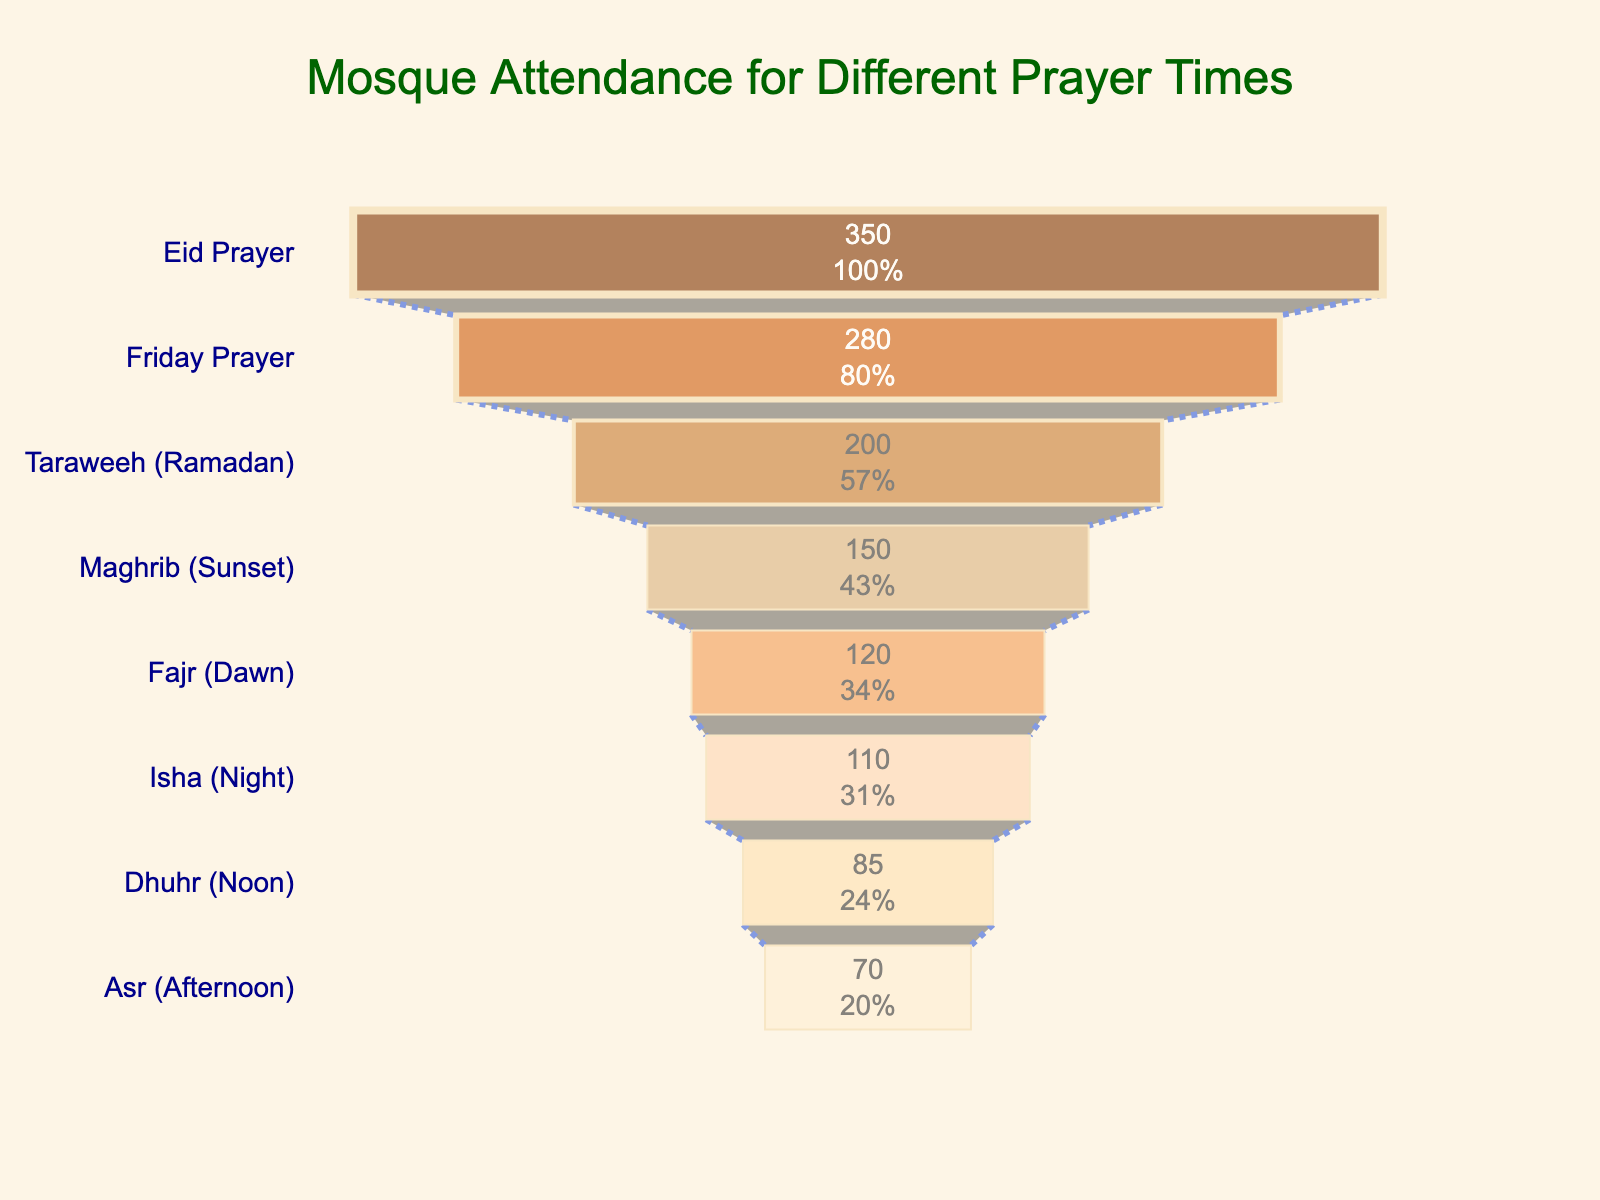what's the title of the funnel chart? The title of the chart is displayed at the top. In this case, it is centered and formatted in a readable font and color.
Answer: Mosque Attendance for Different Prayer Times how many different prayer times are represented in the funnel chart? By counting the different sections of the funnel chart, we can see that there are eight different prayer times shown.
Answer: 8 what prayer time has the highest attendance? We look at the top-most section of the funnel, which represents the prayer time with the highest attendee number.
Answer: Eid Prayer how many people attend the Friday prayer? The funnel segment labeled "Friday Prayer" shows the number of attendees inside. This specific segment indicates the attendee count.
Answer: 280 what's the difference in attendance between Fajr (Dawn) and Isha (Night) prayers? Find the segments for Fajr (Dawn) and Isha (Night) and subtract the smaller number from the larger number: 120 (Fajr) - 110 (Isha)
Answer: 10 which prayer time has fewer attendees, Dhuhr (Noon) or Asr (Afternoon)? Compare the "Dhuhr (Noon)" and "Asr (Afternoon)" segments by looking at their respective attendee counts.
Answer: Asr (Afternoon) how does the attendance for Taraweeh during Ramadan compare to the Friday prayer? Compare the heights of the "Taraweeh (Ramadan)" and "Friday Prayer" segments, noting that the "Friday Prayer" has more attendees.
Answer: Friday Prayer has more attendees what fraction of the total Eid Prayer attendance is represented by Maghrib (Sunset) prayer? Divide the number of attendees for Maghrib (Sunset) by the number for Eid Prayer: 150 / 350
Answer: 3/7 rank the prayer times in descending order of attendance. List all the prayer times by descending the number of attendees displayed in their segments. It will produce the ordered list: Eid Prayer, Taraweeh (Ramadan), Friday Prayer, Maghrib (Sunset), Fajr (Dawn), Isha (Night), Dhuhr (Noon), Asr (Afternoon).
Answer: Eid Prayer > Taraweeh (Ramadan) > Friday Prayer > Maghrib (Sunset) > Fajr (Dawn) > Isha (Night) > Dhuhr (Noon) > Asr (Afternoon) if we combined the attendees of Dhuhr (Noon) and Asr (Afternoon), how would the combined total compare to the Maghrib (Sunset) prayer? Sum the attendees of Dhuhr (Noon) and Asr (Afternoon) (85 + 70 = 155) and compare it to Maghrib (Sunset) with 150 attendees.
Answer: Dhuhr and Asr combined have more 